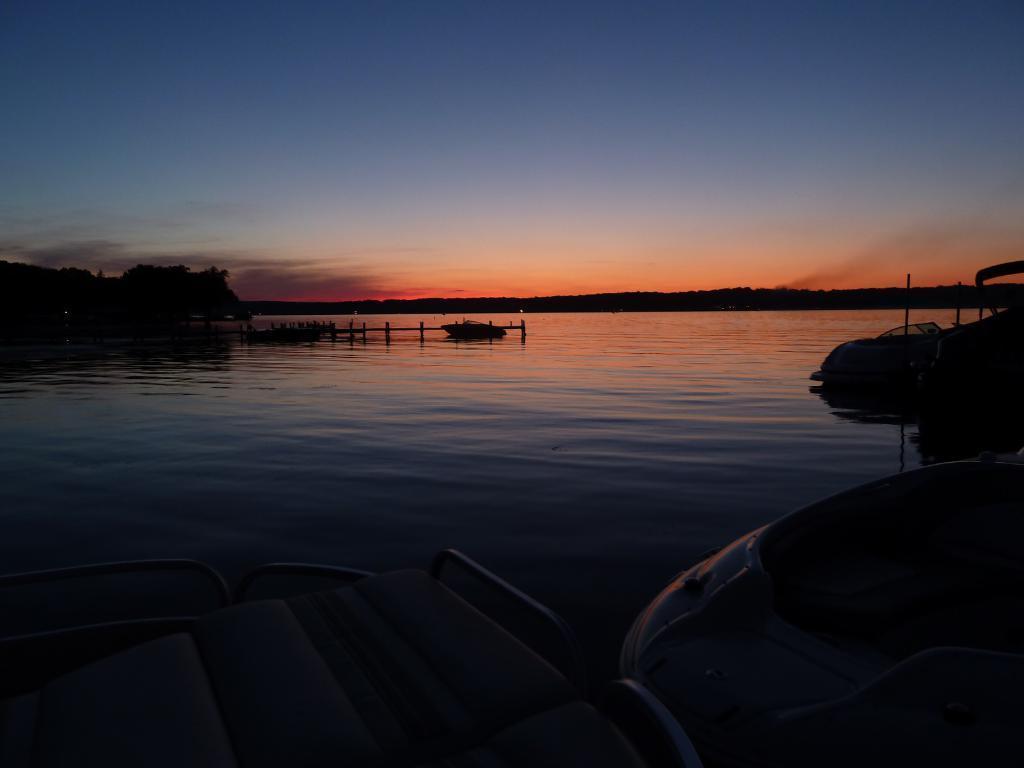Could you give a brief overview of what you see in this image? This picture is taken during the sunset. In this image there is water in the middle. At the bottom there are motor boats in the water. On the left side there are trees. In the middle there is a bridge. At the top there is the sky. 